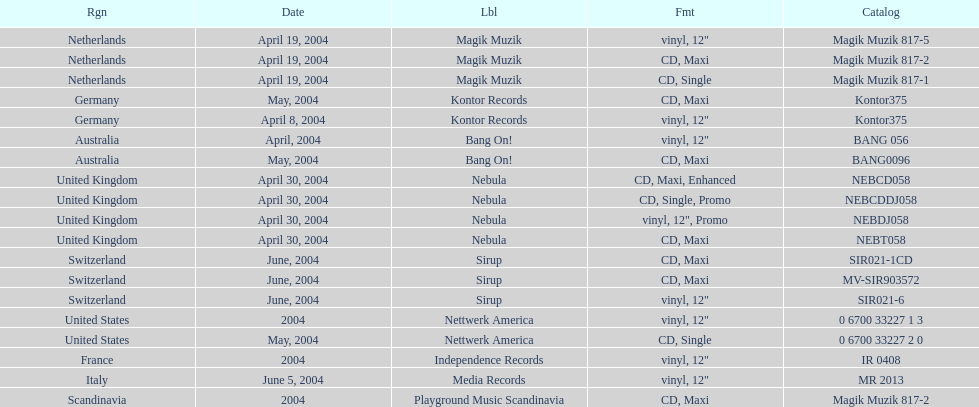What region was on the label sirup? Switzerland. 